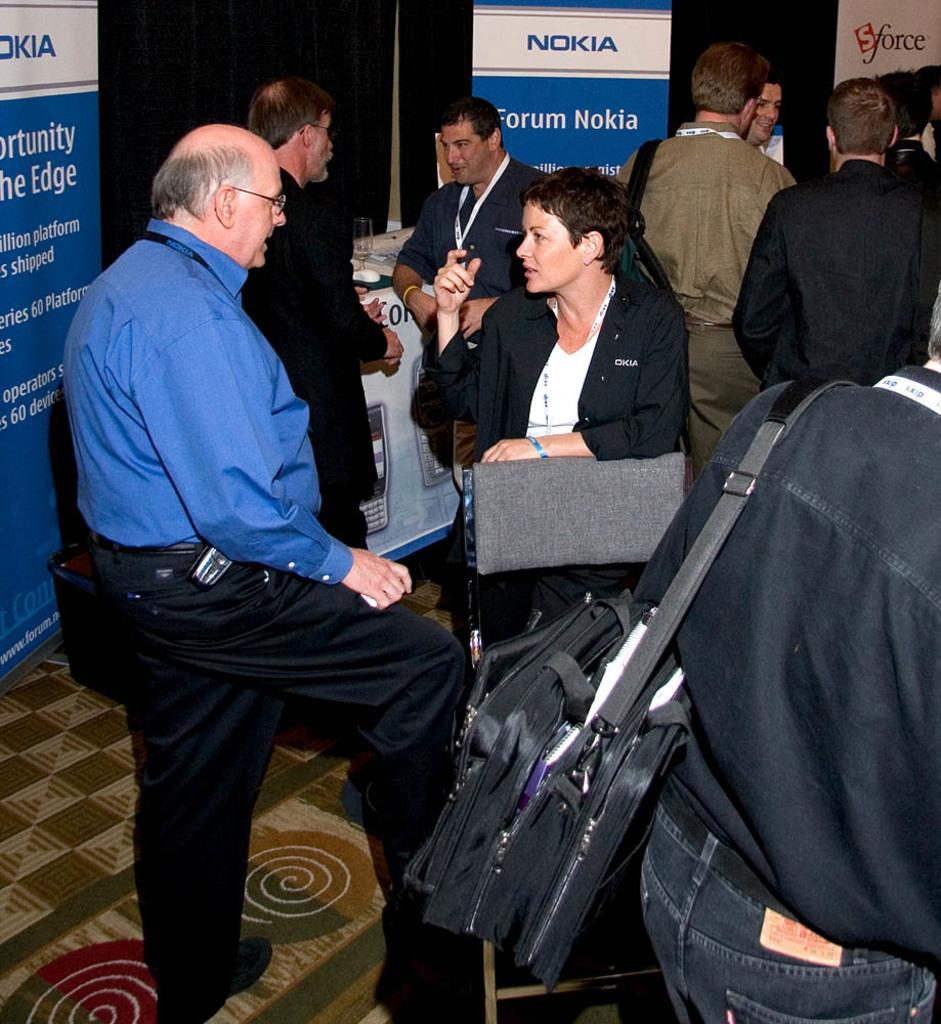In one or two sentences, can you explain what this image depicts? In the foreground of this image, there are few people standing on the floor. On the right there is a man wearing a bag. In the background, there are few banners and, a glass and few objects on the table. 